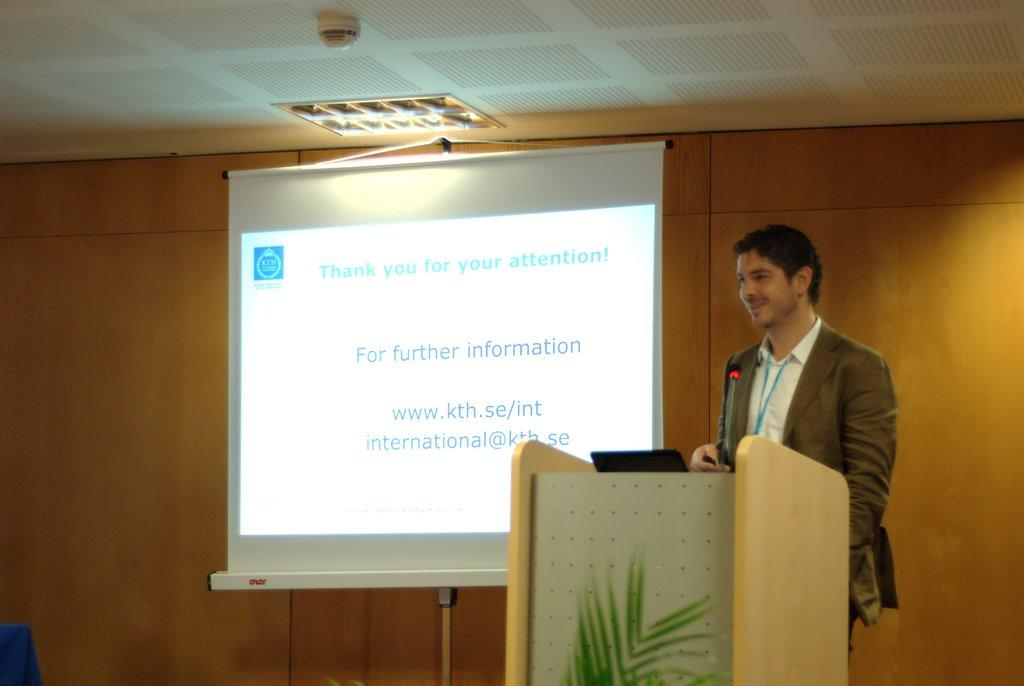<image>
Describe the image concisely. A man at a podium uses a powerpoint for a presentation and is thanking the audience for their participation. 